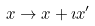<formula> <loc_0><loc_0><loc_500><loc_500>x \to x + \imath x ^ { \prime }</formula> 